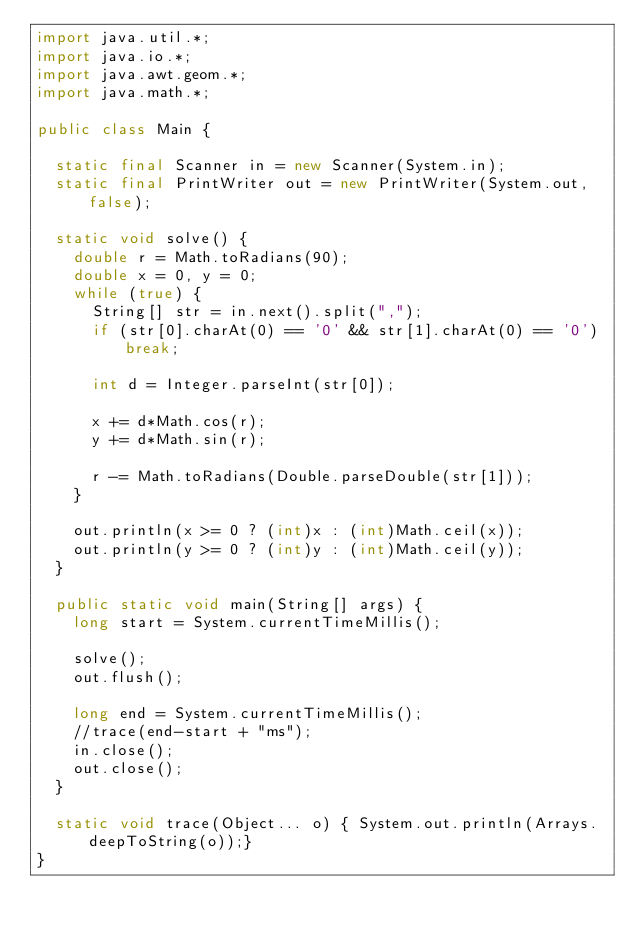<code> <loc_0><loc_0><loc_500><loc_500><_Java_>import java.util.*;
import java.io.*;
import java.awt.geom.*;
import java.math.*;

public class Main {

	static final Scanner in = new Scanner(System.in);
	static final PrintWriter out = new PrintWriter(System.out,false);

	static void solve() {
		double r = Math.toRadians(90);
		double x = 0, y = 0;
		while (true) {
			String[] str = in.next().split(",");
			if (str[0].charAt(0) == '0' && str[1].charAt(0) == '0') break;

			int d = Integer.parseInt(str[0]);

			x += d*Math.cos(r);
			y += d*Math.sin(r);

			r -= Math.toRadians(Double.parseDouble(str[1]));
		}

		out.println(x >= 0 ? (int)x : (int)Math.ceil(x));
		out.println(y >= 0 ? (int)y : (int)Math.ceil(y));
	}

	public static void main(String[] args) {
		long start = System.currentTimeMillis();

		solve();
		out.flush();

		long end = System.currentTimeMillis();
		//trace(end-start + "ms");
		in.close();
		out.close();
	}

	static void trace(Object... o) { System.out.println(Arrays.deepToString(o));}
}</code> 